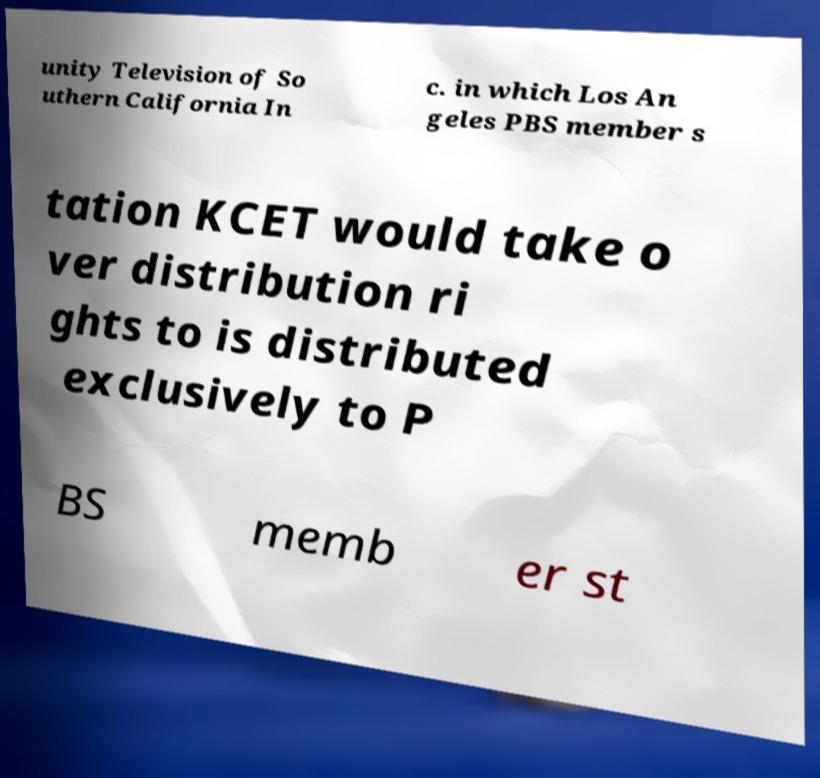Could you extract and type out the text from this image? unity Television of So uthern California In c. in which Los An geles PBS member s tation KCET would take o ver distribution ri ghts to is distributed exclusively to P BS memb er st 